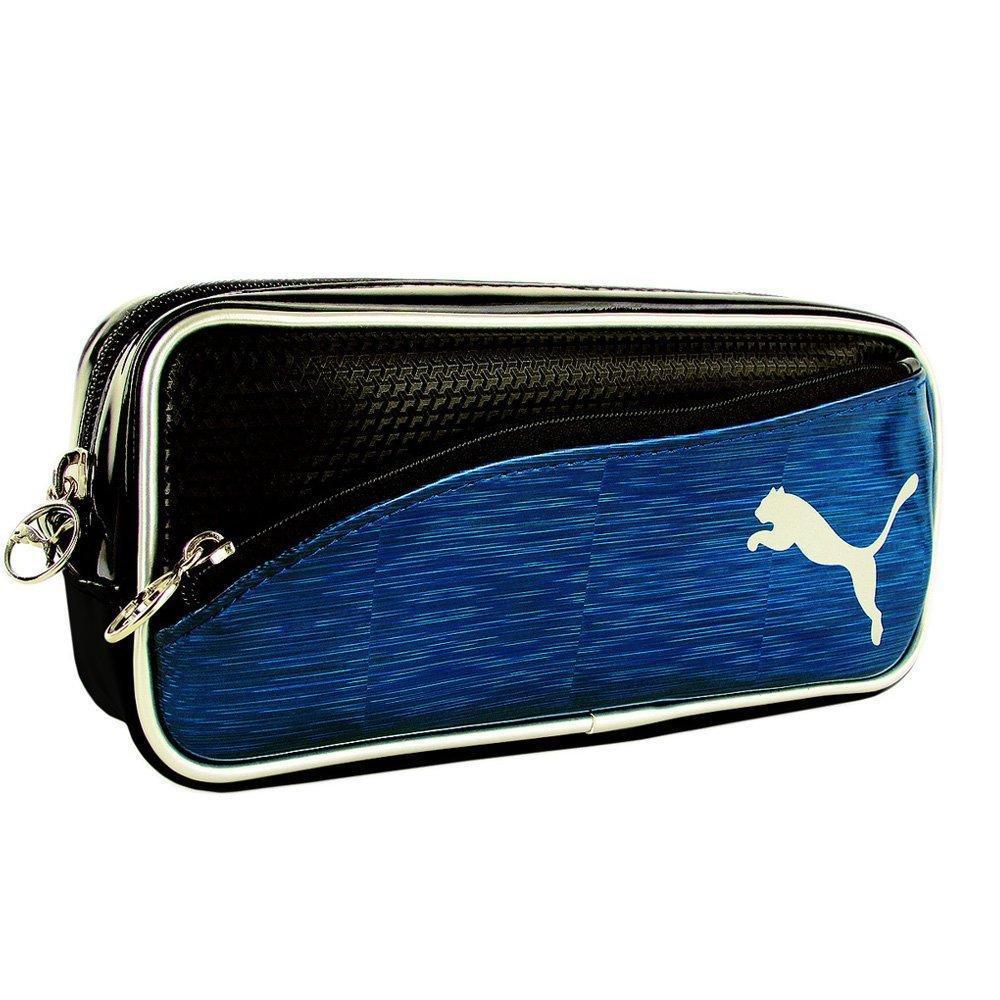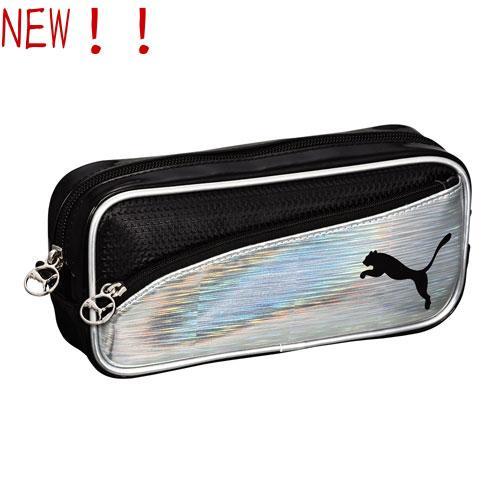The first image is the image on the left, the second image is the image on the right. Examine the images to the left and right. Is the description "Exactly one bag has the company name and the company logo on it." accurate? Answer yes or no. No. The first image is the image on the left, the second image is the image on the right. For the images displayed, is the sentence "Each image contains one pencil case with a wildcat silhouette on it, and the right image features a case with a curving line that separates its colors." factually correct? Answer yes or no. Yes. 